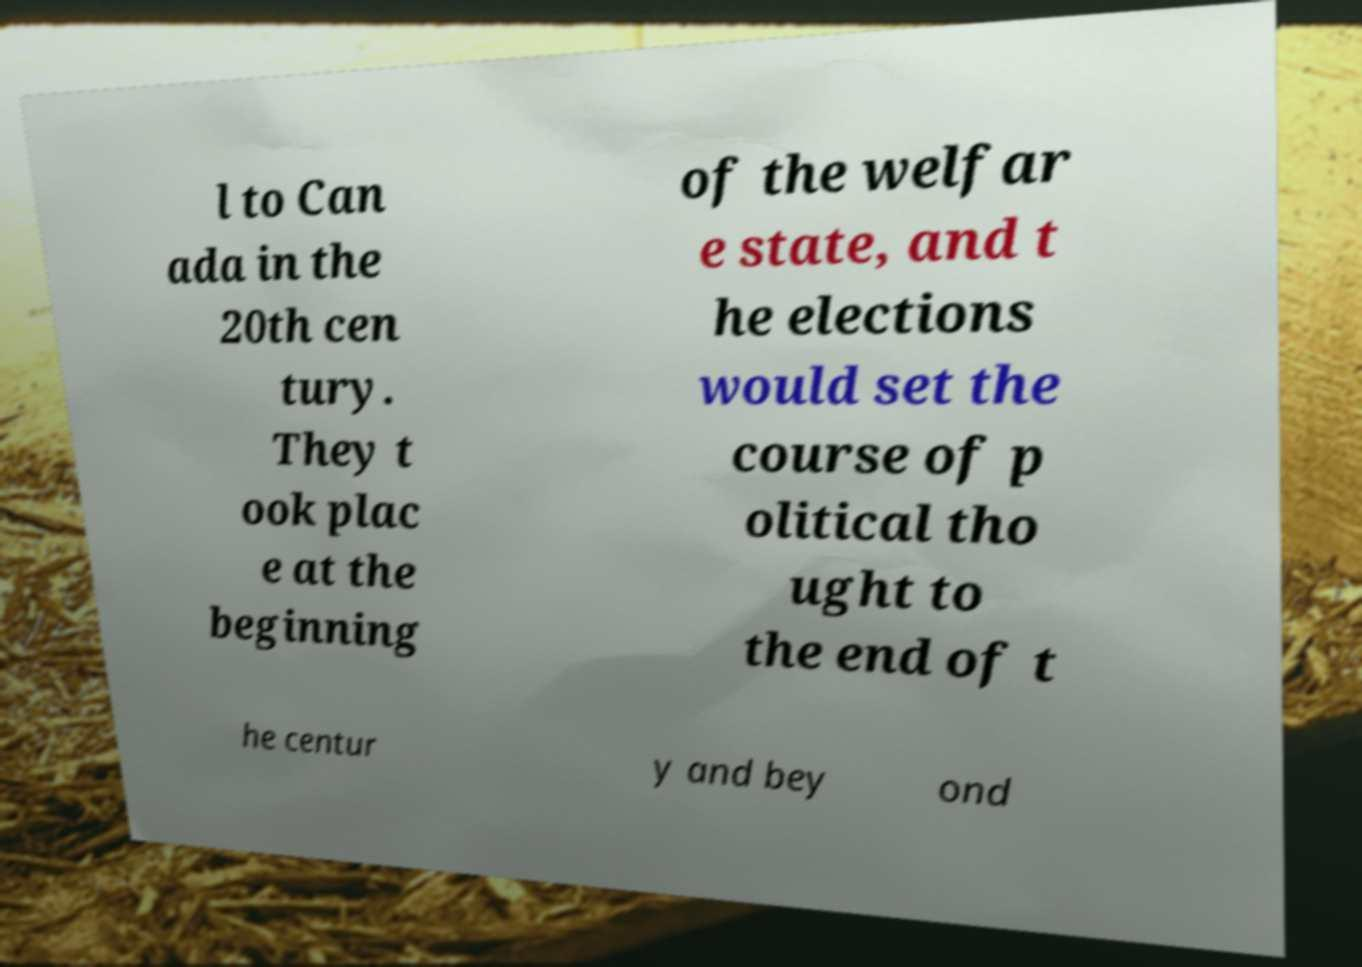Can you accurately transcribe the text from the provided image for me? l to Can ada in the 20th cen tury. They t ook plac e at the beginning of the welfar e state, and t he elections would set the course of p olitical tho ught to the end of t he centur y and bey ond 